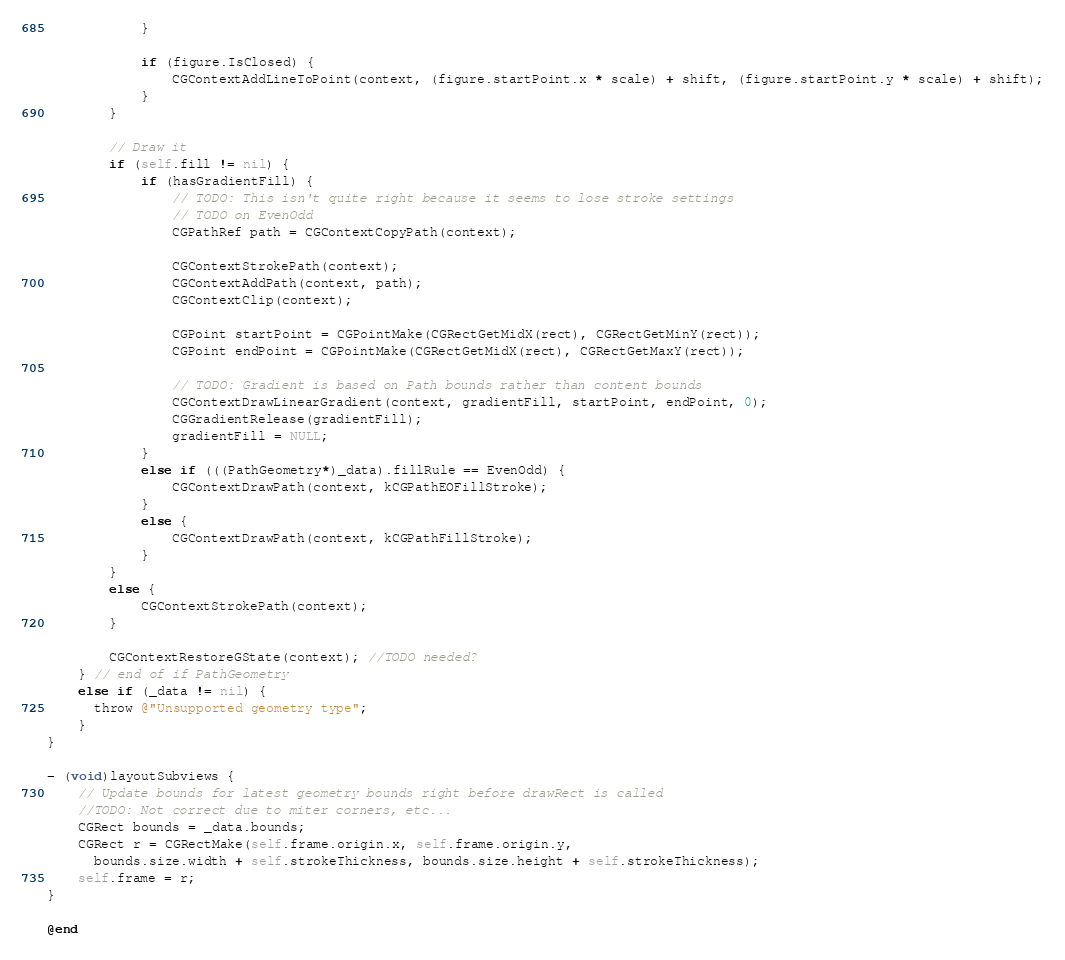<code> <loc_0><loc_0><loc_500><loc_500><_ObjectiveC_>            }

            if (figure.IsClosed) {
                CGContextAddLineToPoint(context, (figure.startPoint.x * scale) + shift, (figure.startPoint.y * scale) + shift);
            }
        }

        // Draw it
        if (self.fill != nil) {
            if (hasGradientFill) {
                // TODO: This isn't quite right because it seems to lose stroke settings
                // TODO on EvenOdd
                CGPathRef path = CGContextCopyPath(context);

                CGContextStrokePath(context);
                CGContextAddPath(context, path);
                CGContextClip(context);

                CGPoint startPoint = CGPointMake(CGRectGetMidX(rect), CGRectGetMinY(rect));
                CGPoint endPoint = CGPointMake(CGRectGetMidX(rect), CGRectGetMaxY(rect));

                // TODO: Gradient is based on Path bounds rather than content bounds
                CGContextDrawLinearGradient(context, gradientFill, startPoint, endPoint, 0);
                CGGradientRelease(gradientFill);
                gradientFill = NULL;
            }
            else if (((PathGeometry*)_data).fillRule == EvenOdd) {
                CGContextDrawPath(context, kCGPathEOFillStroke);
            }
            else {
                CGContextDrawPath(context, kCGPathFillStroke);
            }
        }
        else {
            CGContextStrokePath(context);
        }

        CGContextRestoreGState(context); //TODO needed?
    } // end of if PathGeometry
    else if (_data != nil) {
      throw @"Unsupported geometry type";
    }
}

- (void)layoutSubviews {
    // Update bounds for latest geometry bounds right before drawRect is called
    //TODO: Not correct due to miter corners, etc...
    CGRect bounds = _data.bounds;
    CGRect r = CGRectMake(self.frame.origin.x, self.frame.origin.y,
      bounds.size.width + self.strokeThickness, bounds.size.height + self.strokeThickness);
    self.frame = r;
}

@end
</code> 